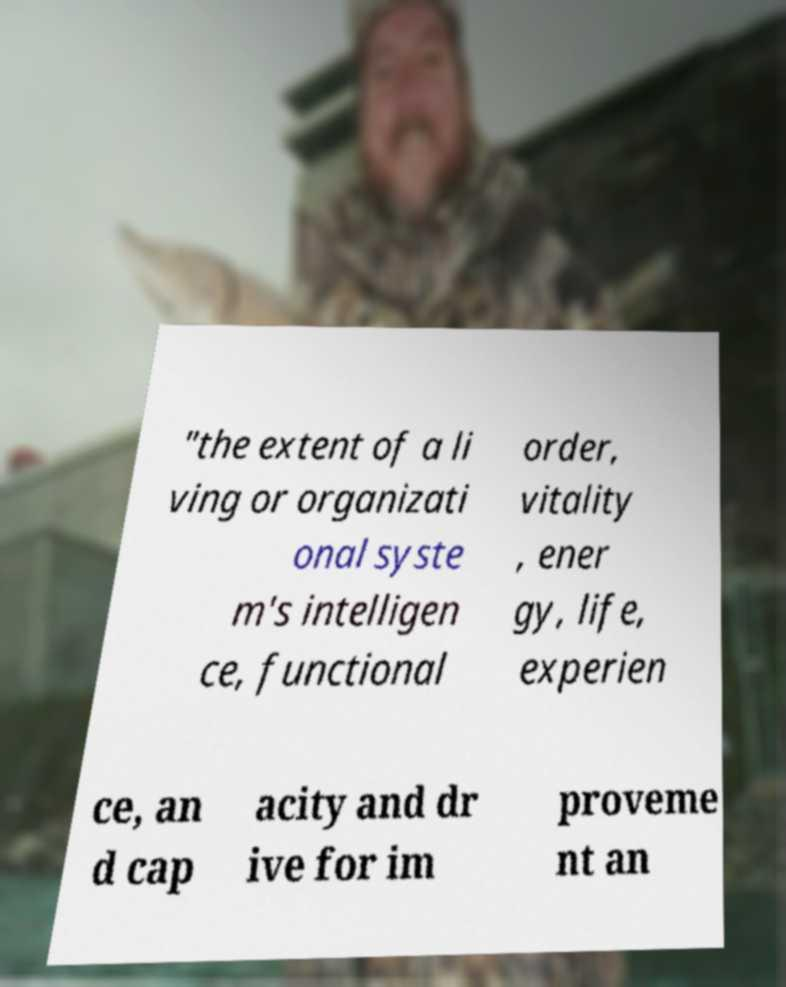Could you extract and type out the text from this image? "the extent of a li ving or organizati onal syste m's intelligen ce, functional order, vitality , ener gy, life, experien ce, an d cap acity and dr ive for im proveme nt an 